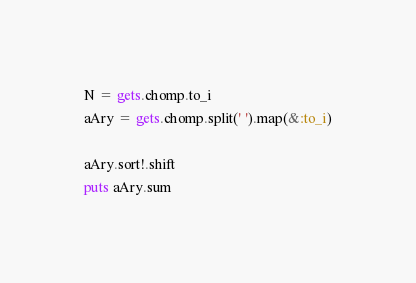Convert code to text. <code><loc_0><loc_0><loc_500><loc_500><_Ruby_>N = gets.chomp.to_i
aAry = gets.chomp.split(' ').map(&:to_i)

aAry.sort!.shift
puts aAry.sum

</code> 